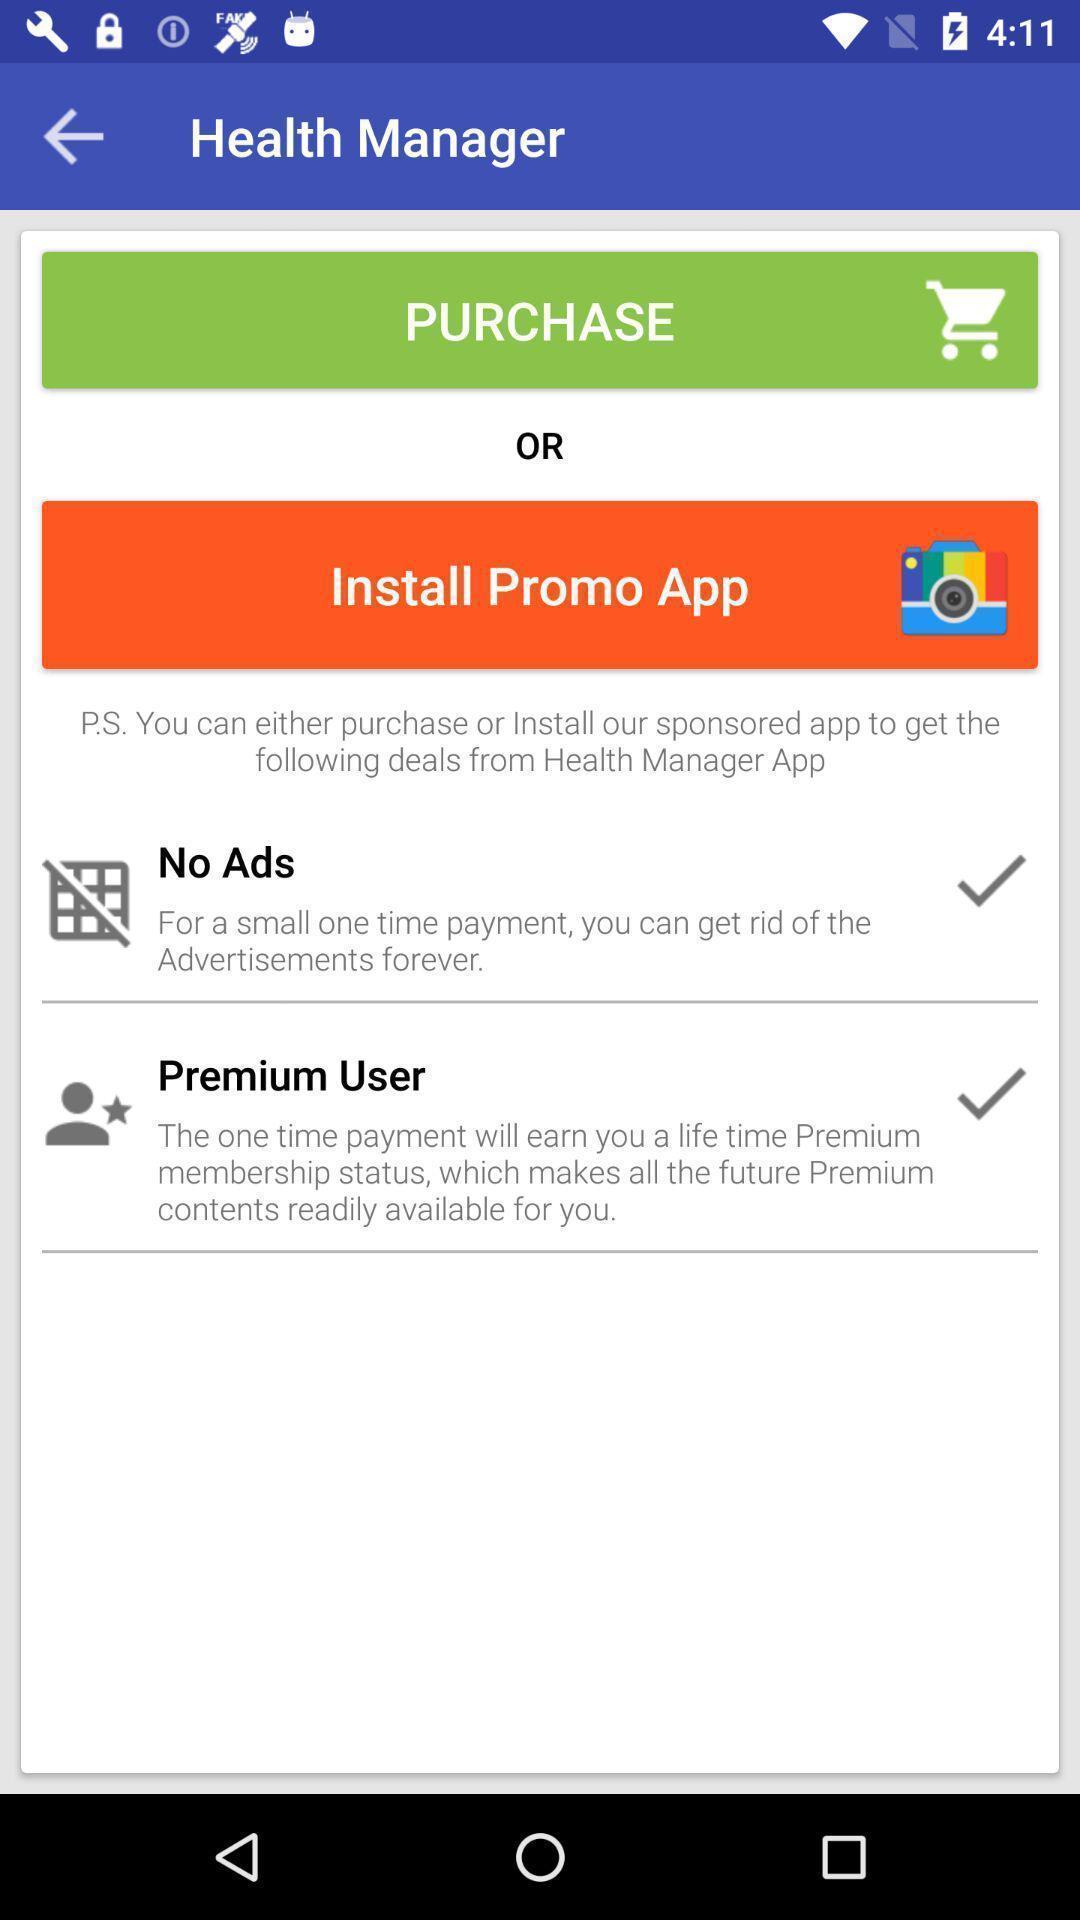Describe this image in words. Two options are displaying to get the health management app. 